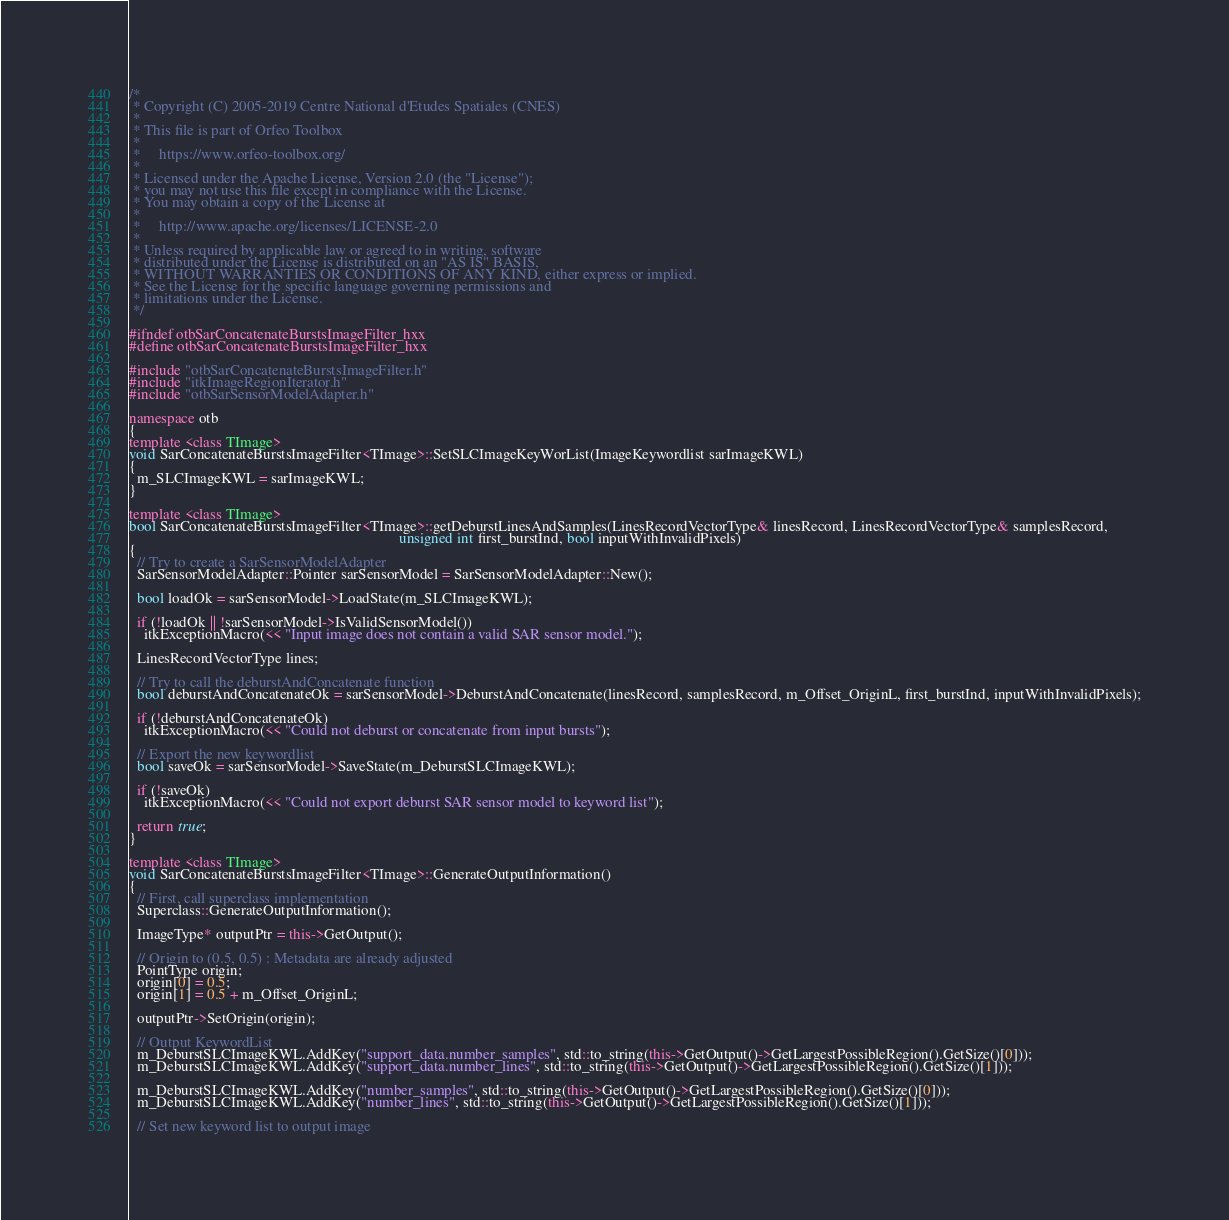Convert code to text. <code><loc_0><loc_0><loc_500><loc_500><_C++_>/*
 * Copyright (C) 2005-2019 Centre National d'Etudes Spatiales (CNES)
 *
 * This file is part of Orfeo Toolbox
 *
 *     https://www.orfeo-toolbox.org/
 *
 * Licensed under the Apache License, Version 2.0 (the "License");
 * you may not use this file except in compliance with the License.
 * You may obtain a copy of the License at
 *
 *     http://www.apache.org/licenses/LICENSE-2.0
 *
 * Unless required by applicable law or agreed to in writing, software
 * distributed under the License is distributed on an "AS IS" BASIS,
 * WITHOUT WARRANTIES OR CONDITIONS OF ANY KIND, either express or implied.
 * See the License for the specific language governing permissions and
 * limitations under the License.
 */

#ifndef otbSarConcatenateBurstsImageFilter_hxx
#define otbSarConcatenateBurstsImageFilter_hxx

#include "otbSarConcatenateBurstsImageFilter.h"
#include "itkImageRegionIterator.h"
#include "otbSarSensorModelAdapter.h"

namespace otb
{
template <class TImage>
void SarConcatenateBurstsImageFilter<TImage>::SetSLCImageKeyWorList(ImageKeywordlist sarImageKWL)
{
  m_SLCImageKWL = sarImageKWL;
}

template <class TImage>
bool SarConcatenateBurstsImageFilter<TImage>::getDeburstLinesAndSamples(LinesRecordVectorType& linesRecord, LinesRecordVectorType& samplesRecord,
                                                                        unsigned int first_burstInd, bool inputWithInvalidPixels)
{
  // Try to create a SarSensorModelAdapter
  SarSensorModelAdapter::Pointer sarSensorModel = SarSensorModelAdapter::New();

  bool loadOk = sarSensorModel->LoadState(m_SLCImageKWL);

  if (!loadOk || !sarSensorModel->IsValidSensorModel())
    itkExceptionMacro(<< "Input image does not contain a valid SAR sensor model.");

  LinesRecordVectorType lines;

  // Try to call the deburstAndConcatenate function
  bool deburstAndConcatenateOk = sarSensorModel->DeburstAndConcatenate(linesRecord, samplesRecord, m_Offset_OriginL, first_burstInd, inputWithInvalidPixels);

  if (!deburstAndConcatenateOk)
    itkExceptionMacro(<< "Could not deburst or concatenate from input bursts");

  // Export the new keywordlist
  bool saveOk = sarSensorModel->SaveState(m_DeburstSLCImageKWL);

  if (!saveOk)
    itkExceptionMacro(<< "Could not export deburst SAR sensor model to keyword list");

  return true;
}

template <class TImage>
void SarConcatenateBurstsImageFilter<TImage>::GenerateOutputInformation()
{
  // First, call superclass implementation
  Superclass::GenerateOutputInformation();

  ImageType* outputPtr = this->GetOutput();

  // Origin to (0.5, 0.5) : Metadata are already adjusted
  PointType origin;
  origin[0] = 0.5;
  origin[1] = 0.5 + m_Offset_OriginL;

  outputPtr->SetOrigin(origin);

  // Output KeywordList
  m_DeburstSLCImageKWL.AddKey("support_data.number_samples", std::to_string(this->GetOutput()->GetLargestPossibleRegion().GetSize()[0]));
  m_DeburstSLCImageKWL.AddKey("support_data.number_lines", std::to_string(this->GetOutput()->GetLargestPossibleRegion().GetSize()[1]));

  m_DeburstSLCImageKWL.AddKey("number_samples", std::to_string(this->GetOutput()->GetLargestPossibleRegion().GetSize()[0]));
  m_DeburstSLCImageKWL.AddKey("number_lines", std::to_string(this->GetOutput()->GetLargestPossibleRegion().GetSize()[1]));

  // Set new keyword list to output image</code> 